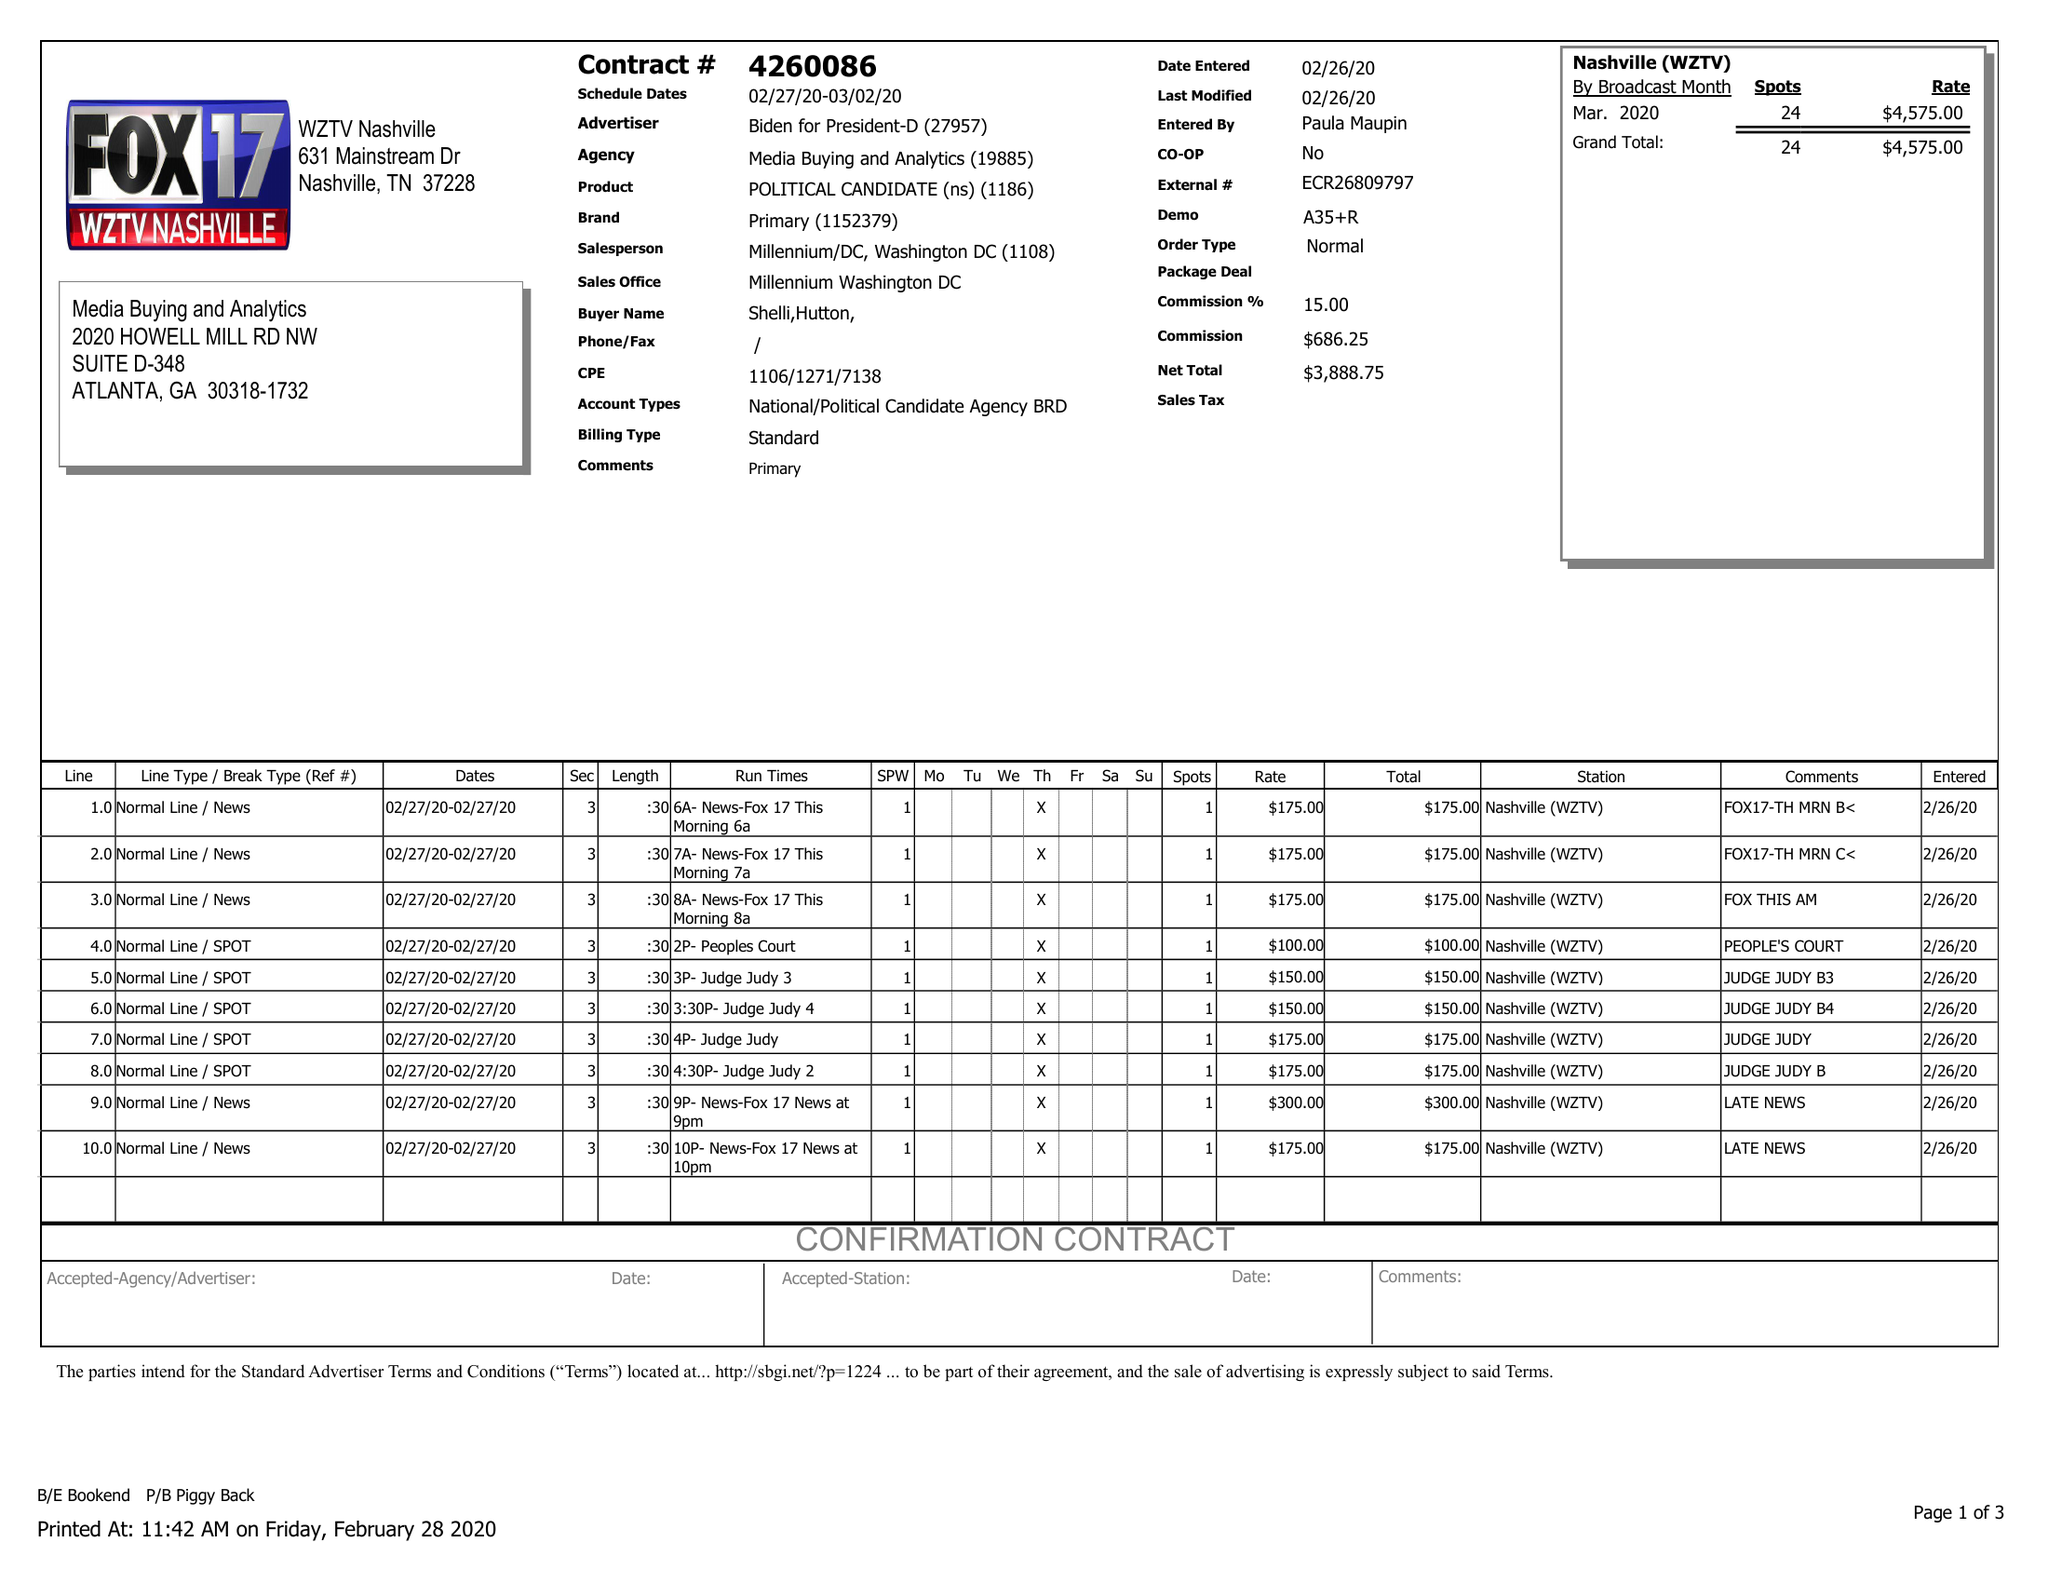What is the value for the flight_from?
Answer the question using a single word or phrase. 02/27/20 